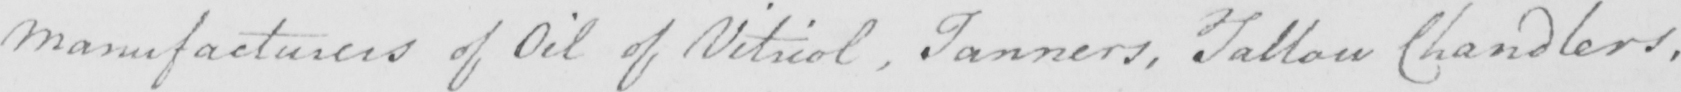Please transcribe the handwritten text in this image. Manufacturers of Oil of Vitriol , Tanners , Tallow Chandlers , 